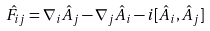<formula> <loc_0><loc_0><loc_500><loc_500>\hat { F } _ { i j } = \nabla _ { i } \hat { A } _ { j } - \nabla _ { j } \hat { A } _ { i } - i [ \hat { A } _ { i } , \hat { A } _ { j } ]</formula> 